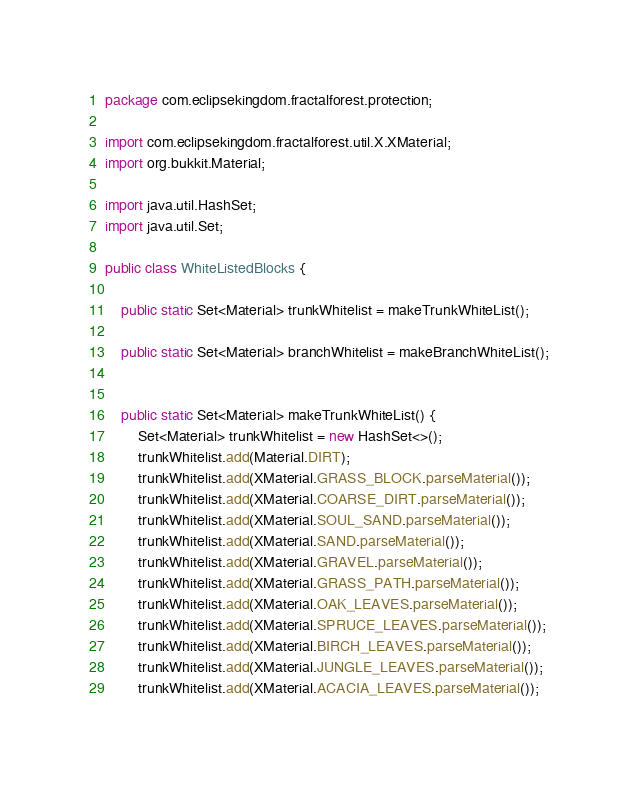Convert code to text. <code><loc_0><loc_0><loc_500><loc_500><_Java_>package com.eclipsekingdom.fractalforest.protection;

import com.eclipsekingdom.fractalforest.util.X.XMaterial;
import org.bukkit.Material;

import java.util.HashSet;
import java.util.Set;

public class WhiteListedBlocks {

    public static Set<Material> trunkWhitelist = makeTrunkWhiteList();

    public static Set<Material> branchWhitelist = makeBranchWhiteList();


    public static Set<Material> makeTrunkWhiteList() {
        Set<Material> trunkWhitelist = new HashSet<>();
        trunkWhitelist.add(Material.DIRT);
        trunkWhitelist.add(XMaterial.GRASS_BLOCK.parseMaterial());
        trunkWhitelist.add(XMaterial.COARSE_DIRT.parseMaterial());
        trunkWhitelist.add(XMaterial.SOUL_SAND.parseMaterial());
        trunkWhitelist.add(XMaterial.SAND.parseMaterial());
        trunkWhitelist.add(XMaterial.GRAVEL.parseMaterial());
        trunkWhitelist.add(XMaterial.GRASS_PATH.parseMaterial());
        trunkWhitelist.add(XMaterial.OAK_LEAVES.parseMaterial());
        trunkWhitelist.add(XMaterial.SPRUCE_LEAVES.parseMaterial());
        trunkWhitelist.add(XMaterial.BIRCH_LEAVES.parseMaterial());
        trunkWhitelist.add(XMaterial.JUNGLE_LEAVES.parseMaterial());
        trunkWhitelist.add(XMaterial.ACACIA_LEAVES.parseMaterial());</code> 